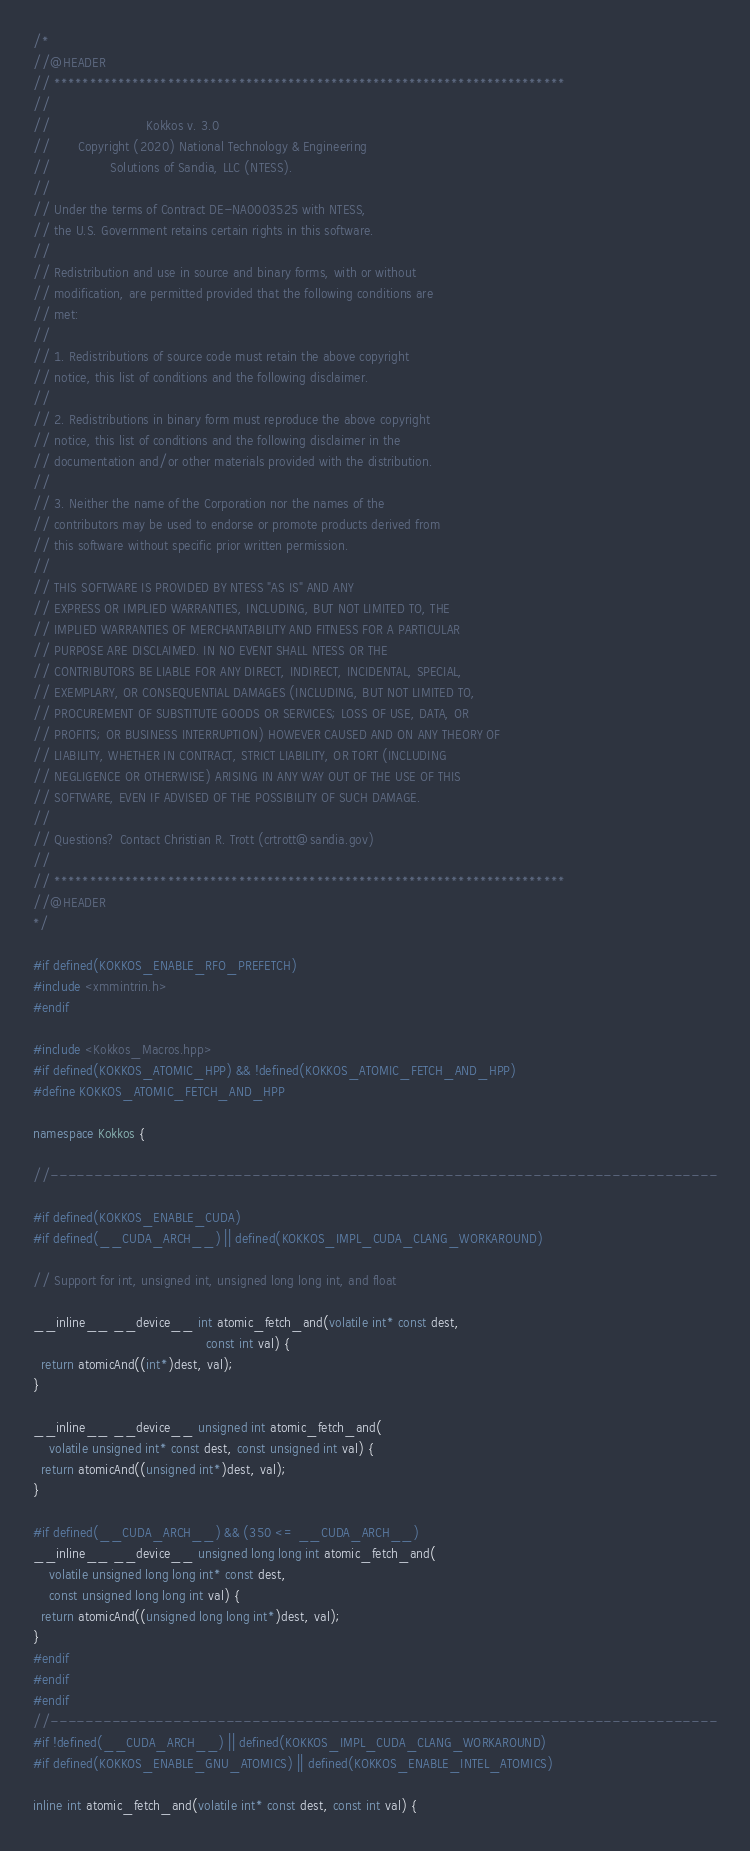Convert code to text. <code><loc_0><loc_0><loc_500><loc_500><_C++_>/*
//@HEADER
// ************************************************************************
//
//                        Kokkos v. 3.0
//       Copyright (2020) National Technology & Engineering
//               Solutions of Sandia, LLC (NTESS).
//
// Under the terms of Contract DE-NA0003525 with NTESS,
// the U.S. Government retains certain rights in this software.
//
// Redistribution and use in source and binary forms, with or without
// modification, are permitted provided that the following conditions are
// met:
//
// 1. Redistributions of source code must retain the above copyright
// notice, this list of conditions and the following disclaimer.
//
// 2. Redistributions in binary form must reproduce the above copyright
// notice, this list of conditions and the following disclaimer in the
// documentation and/or other materials provided with the distribution.
//
// 3. Neither the name of the Corporation nor the names of the
// contributors may be used to endorse or promote products derived from
// this software without specific prior written permission.
//
// THIS SOFTWARE IS PROVIDED BY NTESS "AS IS" AND ANY
// EXPRESS OR IMPLIED WARRANTIES, INCLUDING, BUT NOT LIMITED TO, THE
// IMPLIED WARRANTIES OF MERCHANTABILITY AND FITNESS FOR A PARTICULAR
// PURPOSE ARE DISCLAIMED. IN NO EVENT SHALL NTESS OR THE
// CONTRIBUTORS BE LIABLE FOR ANY DIRECT, INDIRECT, INCIDENTAL, SPECIAL,
// EXEMPLARY, OR CONSEQUENTIAL DAMAGES (INCLUDING, BUT NOT LIMITED TO,
// PROCUREMENT OF SUBSTITUTE GOODS OR SERVICES; LOSS OF USE, DATA, OR
// PROFITS; OR BUSINESS INTERRUPTION) HOWEVER CAUSED AND ON ANY THEORY OF
// LIABILITY, WHETHER IN CONTRACT, STRICT LIABILITY, OR TORT (INCLUDING
// NEGLIGENCE OR OTHERWISE) ARISING IN ANY WAY OUT OF THE USE OF THIS
// SOFTWARE, EVEN IF ADVISED OF THE POSSIBILITY OF SUCH DAMAGE.
//
// Questions? Contact Christian R. Trott (crtrott@sandia.gov)
//
// ************************************************************************
//@HEADER
*/

#if defined(KOKKOS_ENABLE_RFO_PREFETCH)
#include <xmmintrin.h>
#endif

#include <Kokkos_Macros.hpp>
#if defined(KOKKOS_ATOMIC_HPP) && !defined(KOKKOS_ATOMIC_FETCH_AND_HPP)
#define KOKKOS_ATOMIC_FETCH_AND_HPP

namespace Kokkos {

//----------------------------------------------------------------------------

#if defined(KOKKOS_ENABLE_CUDA)
#if defined(__CUDA_ARCH__) || defined(KOKKOS_IMPL_CUDA_CLANG_WORKAROUND)

// Support for int, unsigned int, unsigned long long int, and float

__inline__ __device__ int atomic_fetch_and(volatile int* const dest,
                                           const int val) {
  return atomicAnd((int*)dest, val);
}

__inline__ __device__ unsigned int atomic_fetch_and(
    volatile unsigned int* const dest, const unsigned int val) {
  return atomicAnd((unsigned int*)dest, val);
}

#if defined(__CUDA_ARCH__) && (350 <= __CUDA_ARCH__)
__inline__ __device__ unsigned long long int atomic_fetch_and(
    volatile unsigned long long int* const dest,
    const unsigned long long int val) {
  return atomicAnd((unsigned long long int*)dest, val);
}
#endif
#endif
#endif
//----------------------------------------------------------------------------
#if !defined(__CUDA_ARCH__) || defined(KOKKOS_IMPL_CUDA_CLANG_WORKAROUND)
#if defined(KOKKOS_ENABLE_GNU_ATOMICS) || defined(KOKKOS_ENABLE_INTEL_ATOMICS)

inline int atomic_fetch_and(volatile int* const dest, const int val) {</code> 